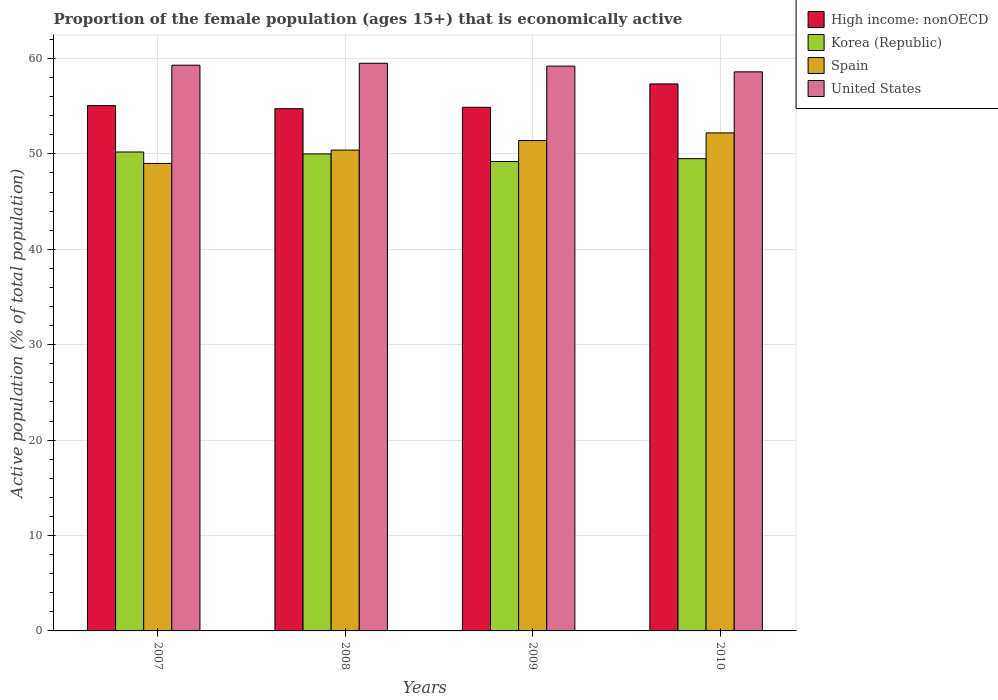How many different coloured bars are there?
Offer a terse response. 4. Are the number of bars on each tick of the X-axis equal?
Your answer should be very brief. Yes. What is the label of the 1st group of bars from the left?
Give a very brief answer. 2007. What is the proportion of the female population that is economically active in High income: nonOECD in 2007?
Keep it short and to the point. 55.06. Across all years, what is the maximum proportion of the female population that is economically active in United States?
Keep it short and to the point. 59.5. Across all years, what is the minimum proportion of the female population that is economically active in Korea (Republic)?
Your response must be concise. 49.2. In which year was the proportion of the female population that is economically active in United States maximum?
Your answer should be very brief. 2008. What is the total proportion of the female population that is economically active in High income: nonOECD in the graph?
Provide a succinct answer. 222.02. What is the difference between the proportion of the female population that is economically active in High income: nonOECD in 2009 and that in 2010?
Your response must be concise. -2.45. What is the difference between the proportion of the female population that is economically active in Spain in 2007 and the proportion of the female population that is economically active in United States in 2009?
Provide a succinct answer. -10.2. What is the average proportion of the female population that is economically active in Spain per year?
Your answer should be compact. 50.75. What is the ratio of the proportion of the female population that is economically active in High income: nonOECD in 2009 to that in 2010?
Keep it short and to the point. 0.96. Is the difference between the proportion of the female population that is economically active in United States in 2007 and 2008 greater than the difference between the proportion of the female population that is economically active in Korea (Republic) in 2007 and 2008?
Provide a short and direct response. No. What is the difference between the highest and the second highest proportion of the female population that is economically active in Korea (Republic)?
Provide a short and direct response. 0.2. What is the difference between the highest and the lowest proportion of the female population that is economically active in Spain?
Make the answer very short. 3.2. In how many years, is the proportion of the female population that is economically active in United States greater than the average proportion of the female population that is economically active in United States taken over all years?
Offer a very short reply. 3. What does the 1st bar from the right in 2009 represents?
Provide a succinct answer. United States. Is it the case that in every year, the sum of the proportion of the female population that is economically active in Spain and proportion of the female population that is economically active in United States is greater than the proportion of the female population that is economically active in Korea (Republic)?
Ensure brevity in your answer.  Yes. How many years are there in the graph?
Ensure brevity in your answer.  4. What is the difference between two consecutive major ticks on the Y-axis?
Your answer should be compact. 10. Does the graph contain grids?
Provide a short and direct response. Yes. Where does the legend appear in the graph?
Give a very brief answer. Top right. How many legend labels are there?
Give a very brief answer. 4. How are the legend labels stacked?
Provide a short and direct response. Vertical. What is the title of the graph?
Provide a succinct answer. Proportion of the female population (ages 15+) that is economically active. What is the label or title of the Y-axis?
Your response must be concise. Active population (% of total population). What is the Active population (% of total population) in High income: nonOECD in 2007?
Make the answer very short. 55.06. What is the Active population (% of total population) of Korea (Republic) in 2007?
Give a very brief answer. 50.2. What is the Active population (% of total population) of United States in 2007?
Offer a very short reply. 59.3. What is the Active population (% of total population) of High income: nonOECD in 2008?
Give a very brief answer. 54.74. What is the Active population (% of total population) of Spain in 2008?
Your answer should be compact. 50.4. What is the Active population (% of total population) of United States in 2008?
Offer a very short reply. 59.5. What is the Active population (% of total population) in High income: nonOECD in 2009?
Provide a succinct answer. 54.88. What is the Active population (% of total population) in Korea (Republic) in 2009?
Your answer should be compact. 49.2. What is the Active population (% of total population) of Spain in 2009?
Offer a very short reply. 51.4. What is the Active population (% of total population) in United States in 2009?
Provide a short and direct response. 59.2. What is the Active population (% of total population) in High income: nonOECD in 2010?
Your response must be concise. 57.34. What is the Active population (% of total population) of Korea (Republic) in 2010?
Make the answer very short. 49.5. What is the Active population (% of total population) of Spain in 2010?
Offer a very short reply. 52.2. What is the Active population (% of total population) in United States in 2010?
Ensure brevity in your answer.  58.6. Across all years, what is the maximum Active population (% of total population) in High income: nonOECD?
Your response must be concise. 57.34. Across all years, what is the maximum Active population (% of total population) in Korea (Republic)?
Offer a terse response. 50.2. Across all years, what is the maximum Active population (% of total population) of Spain?
Your answer should be compact. 52.2. Across all years, what is the maximum Active population (% of total population) in United States?
Make the answer very short. 59.5. Across all years, what is the minimum Active population (% of total population) of High income: nonOECD?
Provide a short and direct response. 54.74. Across all years, what is the minimum Active population (% of total population) in Korea (Republic)?
Offer a very short reply. 49.2. Across all years, what is the minimum Active population (% of total population) of United States?
Ensure brevity in your answer.  58.6. What is the total Active population (% of total population) in High income: nonOECD in the graph?
Keep it short and to the point. 222.02. What is the total Active population (% of total population) of Korea (Republic) in the graph?
Offer a very short reply. 198.9. What is the total Active population (% of total population) of Spain in the graph?
Your answer should be compact. 203. What is the total Active population (% of total population) in United States in the graph?
Your answer should be very brief. 236.6. What is the difference between the Active population (% of total population) in High income: nonOECD in 2007 and that in 2008?
Give a very brief answer. 0.32. What is the difference between the Active population (% of total population) in Korea (Republic) in 2007 and that in 2008?
Your answer should be compact. 0.2. What is the difference between the Active population (% of total population) of Spain in 2007 and that in 2008?
Offer a terse response. -1.4. What is the difference between the Active population (% of total population) in High income: nonOECD in 2007 and that in 2009?
Offer a terse response. 0.18. What is the difference between the Active population (% of total population) of Korea (Republic) in 2007 and that in 2009?
Provide a succinct answer. 1. What is the difference between the Active population (% of total population) of Spain in 2007 and that in 2009?
Keep it short and to the point. -2.4. What is the difference between the Active population (% of total population) of United States in 2007 and that in 2009?
Offer a terse response. 0.1. What is the difference between the Active population (% of total population) of High income: nonOECD in 2007 and that in 2010?
Provide a succinct answer. -2.28. What is the difference between the Active population (% of total population) of Korea (Republic) in 2007 and that in 2010?
Keep it short and to the point. 0.7. What is the difference between the Active population (% of total population) in Spain in 2007 and that in 2010?
Provide a short and direct response. -3.2. What is the difference between the Active population (% of total population) of United States in 2007 and that in 2010?
Keep it short and to the point. 0.7. What is the difference between the Active population (% of total population) in High income: nonOECD in 2008 and that in 2009?
Your answer should be compact. -0.15. What is the difference between the Active population (% of total population) in Korea (Republic) in 2008 and that in 2009?
Give a very brief answer. 0.8. What is the difference between the Active population (% of total population) of Spain in 2008 and that in 2009?
Make the answer very short. -1. What is the difference between the Active population (% of total population) of High income: nonOECD in 2008 and that in 2010?
Give a very brief answer. -2.6. What is the difference between the Active population (% of total population) in Spain in 2008 and that in 2010?
Keep it short and to the point. -1.8. What is the difference between the Active population (% of total population) in High income: nonOECD in 2009 and that in 2010?
Your response must be concise. -2.45. What is the difference between the Active population (% of total population) of Korea (Republic) in 2009 and that in 2010?
Offer a very short reply. -0.3. What is the difference between the Active population (% of total population) in High income: nonOECD in 2007 and the Active population (% of total population) in Korea (Republic) in 2008?
Provide a succinct answer. 5.06. What is the difference between the Active population (% of total population) of High income: nonOECD in 2007 and the Active population (% of total population) of Spain in 2008?
Keep it short and to the point. 4.66. What is the difference between the Active population (% of total population) in High income: nonOECD in 2007 and the Active population (% of total population) in United States in 2008?
Keep it short and to the point. -4.44. What is the difference between the Active population (% of total population) in Korea (Republic) in 2007 and the Active population (% of total population) in Spain in 2008?
Give a very brief answer. -0.2. What is the difference between the Active population (% of total population) in Korea (Republic) in 2007 and the Active population (% of total population) in United States in 2008?
Ensure brevity in your answer.  -9.3. What is the difference between the Active population (% of total population) of Spain in 2007 and the Active population (% of total population) of United States in 2008?
Your answer should be very brief. -10.5. What is the difference between the Active population (% of total population) of High income: nonOECD in 2007 and the Active population (% of total population) of Korea (Republic) in 2009?
Ensure brevity in your answer.  5.86. What is the difference between the Active population (% of total population) in High income: nonOECD in 2007 and the Active population (% of total population) in Spain in 2009?
Your answer should be very brief. 3.66. What is the difference between the Active population (% of total population) in High income: nonOECD in 2007 and the Active population (% of total population) in United States in 2009?
Make the answer very short. -4.14. What is the difference between the Active population (% of total population) in Korea (Republic) in 2007 and the Active population (% of total population) in Spain in 2009?
Provide a short and direct response. -1.2. What is the difference between the Active population (% of total population) of Spain in 2007 and the Active population (% of total population) of United States in 2009?
Provide a short and direct response. -10.2. What is the difference between the Active population (% of total population) of High income: nonOECD in 2007 and the Active population (% of total population) of Korea (Republic) in 2010?
Ensure brevity in your answer.  5.56. What is the difference between the Active population (% of total population) in High income: nonOECD in 2007 and the Active population (% of total population) in Spain in 2010?
Offer a terse response. 2.86. What is the difference between the Active population (% of total population) in High income: nonOECD in 2007 and the Active population (% of total population) in United States in 2010?
Provide a short and direct response. -3.54. What is the difference between the Active population (% of total population) in High income: nonOECD in 2008 and the Active population (% of total population) in Korea (Republic) in 2009?
Ensure brevity in your answer.  5.54. What is the difference between the Active population (% of total population) of High income: nonOECD in 2008 and the Active population (% of total population) of Spain in 2009?
Ensure brevity in your answer.  3.34. What is the difference between the Active population (% of total population) in High income: nonOECD in 2008 and the Active population (% of total population) in United States in 2009?
Your answer should be very brief. -4.46. What is the difference between the Active population (% of total population) in Korea (Republic) in 2008 and the Active population (% of total population) in Spain in 2009?
Provide a succinct answer. -1.4. What is the difference between the Active population (% of total population) in Korea (Republic) in 2008 and the Active population (% of total population) in United States in 2009?
Ensure brevity in your answer.  -9.2. What is the difference between the Active population (% of total population) in High income: nonOECD in 2008 and the Active population (% of total population) in Korea (Republic) in 2010?
Offer a terse response. 5.24. What is the difference between the Active population (% of total population) of High income: nonOECD in 2008 and the Active population (% of total population) of Spain in 2010?
Make the answer very short. 2.54. What is the difference between the Active population (% of total population) of High income: nonOECD in 2008 and the Active population (% of total population) of United States in 2010?
Provide a succinct answer. -3.86. What is the difference between the Active population (% of total population) of Korea (Republic) in 2008 and the Active population (% of total population) of Spain in 2010?
Your response must be concise. -2.2. What is the difference between the Active population (% of total population) in Spain in 2008 and the Active population (% of total population) in United States in 2010?
Offer a very short reply. -8.2. What is the difference between the Active population (% of total population) in High income: nonOECD in 2009 and the Active population (% of total population) in Korea (Republic) in 2010?
Keep it short and to the point. 5.38. What is the difference between the Active population (% of total population) of High income: nonOECD in 2009 and the Active population (% of total population) of Spain in 2010?
Give a very brief answer. 2.68. What is the difference between the Active population (% of total population) in High income: nonOECD in 2009 and the Active population (% of total population) in United States in 2010?
Ensure brevity in your answer.  -3.72. What is the difference between the Active population (% of total population) in Korea (Republic) in 2009 and the Active population (% of total population) in Spain in 2010?
Give a very brief answer. -3. What is the difference between the Active population (% of total population) in Korea (Republic) in 2009 and the Active population (% of total population) in United States in 2010?
Your response must be concise. -9.4. What is the difference between the Active population (% of total population) in Spain in 2009 and the Active population (% of total population) in United States in 2010?
Offer a very short reply. -7.2. What is the average Active population (% of total population) in High income: nonOECD per year?
Offer a very short reply. 55.5. What is the average Active population (% of total population) of Korea (Republic) per year?
Offer a terse response. 49.73. What is the average Active population (% of total population) in Spain per year?
Offer a very short reply. 50.75. What is the average Active population (% of total population) of United States per year?
Your response must be concise. 59.15. In the year 2007, what is the difference between the Active population (% of total population) in High income: nonOECD and Active population (% of total population) in Korea (Republic)?
Your answer should be very brief. 4.86. In the year 2007, what is the difference between the Active population (% of total population) in High income: nonOECD and Active population (% of total population) in Spain?
Give a very brief answer. 6.06. In the year 2007, what is the difference between the Active population (% of total population) of High income: nonOECD and Active population (% of total population) of United States?
Keep it short and to the point. -4.24. In the year 2007, what is the difference between the Active population (% of total population) of Spain and Active population (% of total population) of United States?
Offer a very short reply. -10.3. In the year 2008, what is the difference between the Active population (% of total population) of High income: nonOECD and Active population (% of total population) of Korea (Republic)?
Provide a short and direct response. 4.74. In the year 2008, what is the difference between the Active population (% of total population) in High income: nonOECD and Active population (% of total population) in Spain?
Offer a terse response. 4.34. In the year 2008, what is the difference between the Active population (% of total population) of High income: nonOECD and Active population (% of total population) of United States?
Give a very brief answer. -4.76. In the year 2009, what is the difference between the Active population (% of total population) in High income: nonOECD and Active population (% of total population) in Korea (Republic)?
Keep it short and to the point. 5.68. In the year 2009, what is the difference between the Active population (% of total population) of High income: nonOECD and Active population (% of total population) of Spain?
Offer a very short reply. 3.48. In the year 2009, what is the difference between the Active population (% of total population) of High income: nonOECD and Active population (% of total population) of United States?
Make the answer very short. -4.32. In the year 2009, what is the difference between the Active population (% of total population) in Korea (Republic) and Active population (% of total population) in Spain?
Provide a succinct answer. -2.2. In the year 2009, what is the difference between the Active population (% of total population) of Korea (Republic) and Active population (% of total population) of United States?
Make the answer very short. -10. In the year 2009, what is the difference between the Active population (% of total population) in Spain and Active population (% of total population) in United States?
Make the answer very short. -7.8. In the year 2010, what is the difference between the Active population (% of total population) of High income: nonOECD and Active population (% of total population) of Korea (Republic)?
Offer a terse response. 7.84. In the year 2010, what is the difference between the Active population (% of total population) of High income: nonOECD and Active population (% of total population) of Spain?
Your answer should be compact. 5.14. In the year 2010, what is the difference between the Active population (% of total population) in High income: nonOECD and Active population (% of total population) in United States?
Make the answer very short. -1.26. In the year 2010, what is the difference between the Active population (% of total population) in Korea (Republic) and Active population (% of total population) in Spain?
Make the answer very short. -2.7. In the year 2010, what is the difference between the Active population (% of total population) of Spain and Active population (% of total population) of United States?
Your answer should be compact. -6.4. What is the ratio of the Active population (% of total population) of High income: nonOECD in 2007 to that in 2008?
Your response must be concise. 1.01. What is the ratio of the Active population (% of total population) in Spain in 2007 to that in 2008?
Your answer should be very brief. 0.97. What is the ratio of the Active population (% of total population) in High income: nonOECD in 2007 to that in 2009?
Ensure brevity in your answer.  1. What is the ratio of the Active population (% of total population) of Korea (Republic) in 2007 to that in 2009?
Give a very brief answer. 1.02. What is the ratio of the Active population (% of total population) of Spain in 2007 to that in 2009?
Your answer should be compact. 0.95. What is the ratio of the Active population (% of total population) in United States in 2007 to that in 2009?
Offer a very short reply. 1. What is the ratio of the Active population (% of total population) in High income: nonOECD in 2007 to that in 2010?
Give a very brief answer. 0.96. What is the ratio of the Active population (% of total population) of Korea (Republic) in 2007 to that in 2010?
Your response must be concise. 1.01. What is the ratio of the Active population (% of total population) in Spain in 2007 to that in 2010?
Your answer should be compact. 0.94. What is the ratio of the Active population (% of total population) in United States in 2007 to that in 2010?
Keep it short and to the point. 1.01. What is the ratio of the Active population (% of total population) of Korea (Republic) in 2008 to that in 2009?
Your answer should be very brief. 1.02. What is the ratio of the Active population (% of total population) in Spain in 2008 to that in 2009?
Keep it short and to the point. 0.98. What is the ratio of the Active population (% of total population) in United States in 2008 to that in 2009?
Offer a very short reply. 1.01. What is the ratio of the Active population (% of total population) in High income: nonOECD in 2008 to that in 2010?
Provide a short and direct response. 0.95. What is the ratio of the Active population (% of total population) of Korea (Republic) in 2008 to that in 2010?
Your response must be concise. 1.01. What is the ratio of the Active population (% of total population) of Spain in 2008 to that in 2010?
Your answer should be very brief. 0.97. What is the ratio of the Active population (% of total population) of United States in 2008 to that in 2010?
Offer a very short reply. 1.02. What is the ratio of the Active population (% of total population) in High income: nonOECD in 2009 to that in 2010?
Your answer should be compact. 0.96. What is the ratio of the Active population (% of total population) of Spain in 2009 to that in 2010?
Give a very brief answer. 0.98. What is the ratio of the Active population (% of total population) in United States in 2009 to that in 2010?
Provide a short and direct response. 1.01. What is the difference between the highest and the second highest Active population (% of total population) of High income: nonOECD?
Give a very brief answer. 2.28. What is the difference between the highest and the lowest Active population (% of total population) of High income: nonOECD?
Offer a very short reply. 2.6. What is the difference between the highest and the lowest Active population (% of total population) of Korea (Republic)?
Give a very brief answer. 1. 